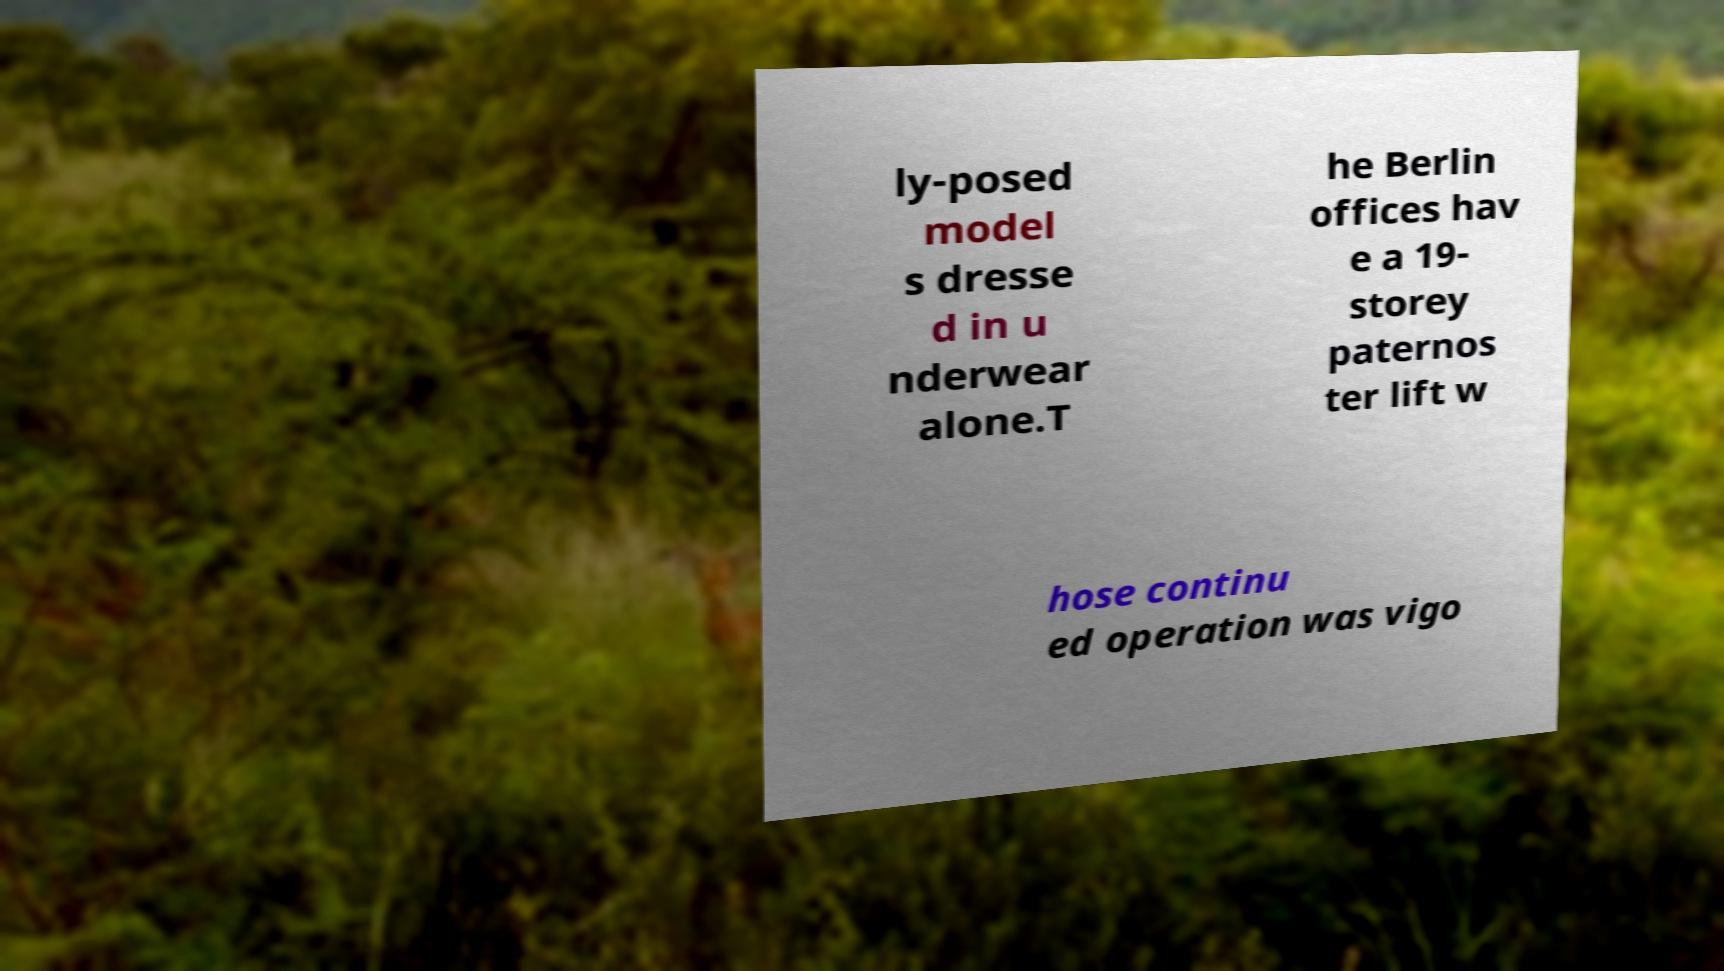Please identify and transcribe the text found in this image. ly-posed model s dresse d in u nderwear alone.T he Berlin offices hav e a 19- storey paternos ter lift w hose continu ed operation was vigo 